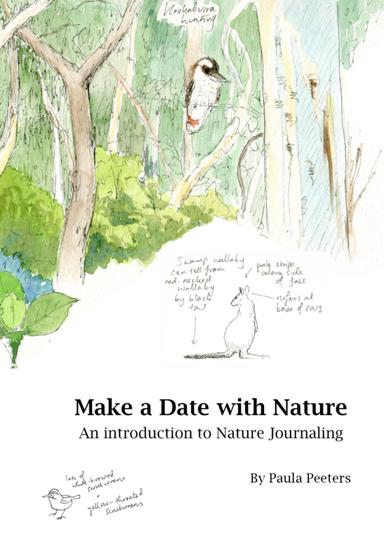How can nature journaling benefit mental health according to the image? Nature journaling, as depicted in the image, can significantly benefit mental health by providing a peaceful and meditative activity that promotes relaxation and mindfulness. It fosters a deep connection with nature, which has been shown to reduce stress, anxiety, and improve mood. 